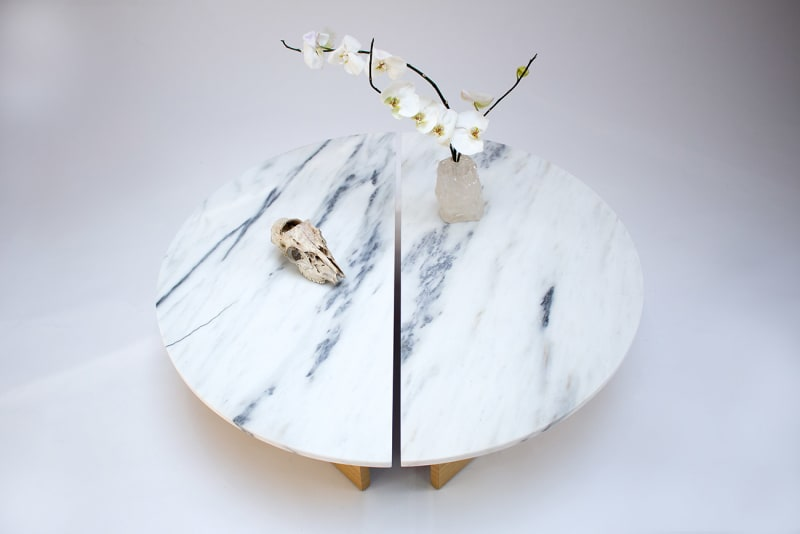Considering the items displayed on the table, what could be the underlying theme or purpose of this arrangement? The elegant marble table provides a sophisticated background to the thoughtfully placed items, each contributing to a theme that juxtaposes the permanence of materials with ephemeral life. The white orchid represents delicate beauty and ephemeral life, contrasting with the enduring, pristine crystal quartz. The bird skull, likely from a small species, adds a poignant reminder of life's fragility and the inevitable cycle of nature. Together, these elements might suggest a reflective space designed to contemplate life's temporality and the enduring beauty found in nature and art. 